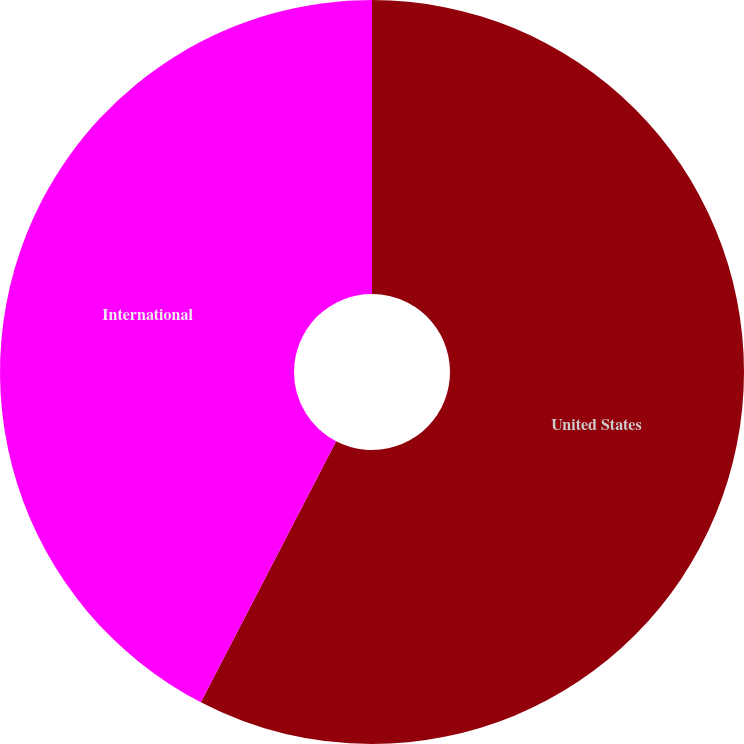<chart> <loc_0><loc_0><loc_500><loc_500><pie_chart><fcel>United States<fcel>International<nl><fcel>57.61%<fcel>42.39%<nl></chart> 